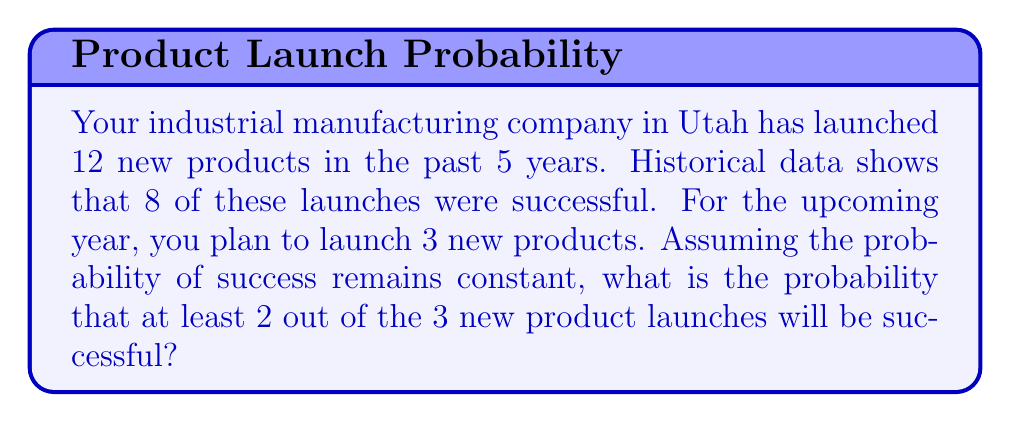Could you help me with this problem? Let's approach this step-by-step:

1) First, we need to calculate the probability of a single product launch being successful based on historical data:

   $p = \frac{\text{number of successful launches}}{\text{total number of launches}} = \frac{8}{12} = \frac{2}{3}$

2) The probability of failure for a single launch is:

   $q = 1 - p = 1 - \frac{2}{3} = \frac{1}{3}$

3) We want the probability of at least 2 out of 3 launches being successful. This can happen in two ways:
   - All 3 launches are successful
   - Exactly 2 out of 3 launches are successful

4) Let's calculate these probabilities using the binomial probability formula:

   $P(X=k) = \binom{n}{k} p^k q^{n-k}$

   where $n$ is the number of trials, $k$ is the number of successes, $p$ is the probability of success, and $q$ is the probability of failure.

5) Probability of all 3 launches being successful:

   $P(X=3) = \binom{3}{3} (\frac{2}{3})^3 (\frac{1}{3})^0 = 1 \cdot (\frac{8}{27}) \cdot 1 = \frac{8}{27}$

6) Probability of exactly 2 out of 3 launches being successful:

   $P(X=2) = \binom{3}{2} (\frac{2}{3})^2 (\frac{1}{3})^1 = 3 \cdot (\frac{4}{9}) \cdot (\frac{1}{3}) = \frac{4}{9}$

7) The probability of at least 2 out of 3 launches being successful is the sum of these probabilities:

   $P(X \geq 2) = P(X=2) + P(X=3) = \frac{4}{9} + \frac{8}{27} = \frac{12}{27} + \frac{8}{27} = \frac{20}{27}$
Answer: $\frac{20}{27}$ or approximately $0.7407$ 